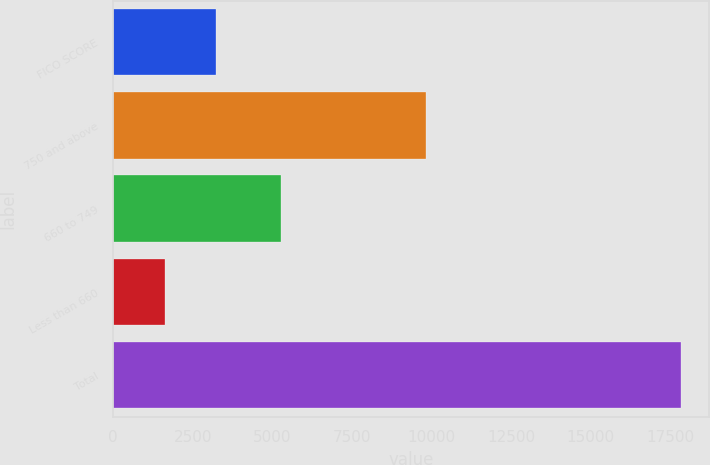<chart> <loc_0><loc_0><loc_500><loc_500><bar_chart><fcel>FICO SCORE<fcel>750 and above<fcel>660 to 749<fcel>Less than 660<fcel>Total<nl><fcel>3237.6<fcel>9818<fcel>5266<fcel>1617<fcel>17823<nl></chart> 